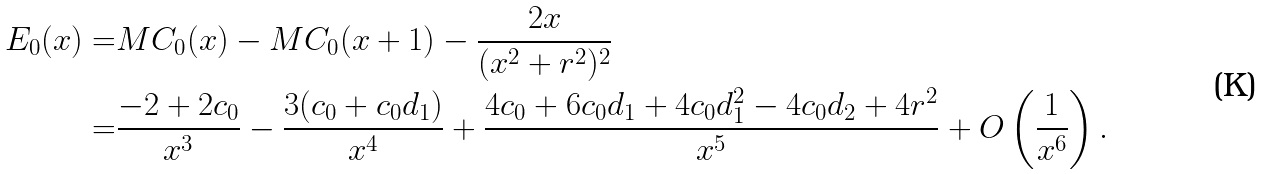Convert formula to latex. <formula><loc_0><loc_0><loc_500><loc_500>E _ { 0 } ( x ) = & M C _ { 0 } ( x ) - M C _ { 0 } ( x + 1 ) - \frac { 2 x } { ( x ^ { 2 } + r ^ { 2 } ) ^ { 2 } } \\ = & \frac { - 2 + 2 c _ { 0 } } { x ^ { 3 } } - \frac { 3 ( c _ { 0 } + c _ { 0 } d _ { 1 } ) } { x ^ { 4 } } + \frac { 4 c _ { 0 } + 6 c _ { 0 } d _ { 1 } + 4 c _ { 0 } d _ { 1 } ^ { 2 } - 4 c _ { 0 } d _ { 2 } + 4 r ^ { 2 } } { x ^ { 5 } } + O \left ( \frac { 1 } { x ^ { 6 } } \right ) .</formula> 